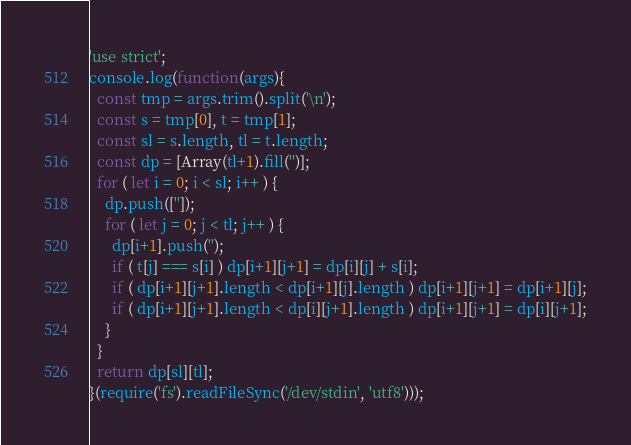Convert code to text. <code><loc_0><loc_0><loc_500><loc_500><_JavaScript_>'use strict';
console.log(function(args){
  const tmp = args.trim().split('\n');
  const s = tmp[0], t = tmp[1];
  const sl = s.length, tl = t.length;
  const dp = [Array(tl+1).fill('')];
  for ( let i = 0; i < sl; i++ ) {
    dp.push(['']);
    for ( let j = 0; j < tl; j++ ) {
      dp[i+1].push('');
      if ( t[j] === s[i] ) dp[i+1][j+1] = dp[i][j] + s[i];
      if ( dp[i+1][j+1].length < dp[i+1][j].length ) dp[i+1][j+1] = dp[i+1][j];
      if ( dp[i+1][j+1].length < dp[i][j+1].length ) dp[i+1][j+1] = dp[i][j+1];
    }
  }
  return dp[sl][tl];
}(require('fs').readFileSync('/dev/stdin', 'utf8')));
</code> 